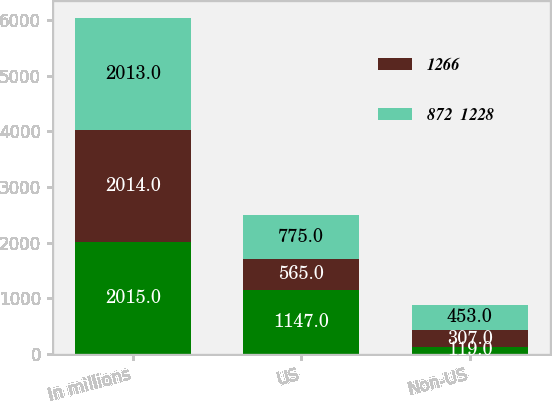Convert chart. <chart><loc_0><loc_0><loc_500><loc_500><stacked_bar_chart><ecel><fcel>In millions<fcel>US<fcel>Non-US<nl><fcel>nan<fcel>2015<fcel>1147<fcel>119<nl><fcel>1266<fcel>2014<fcel>565<fcel>307<nl><fcel>872  1228<fcel>2013<fcel>775<fcel>453<nl></chart> 